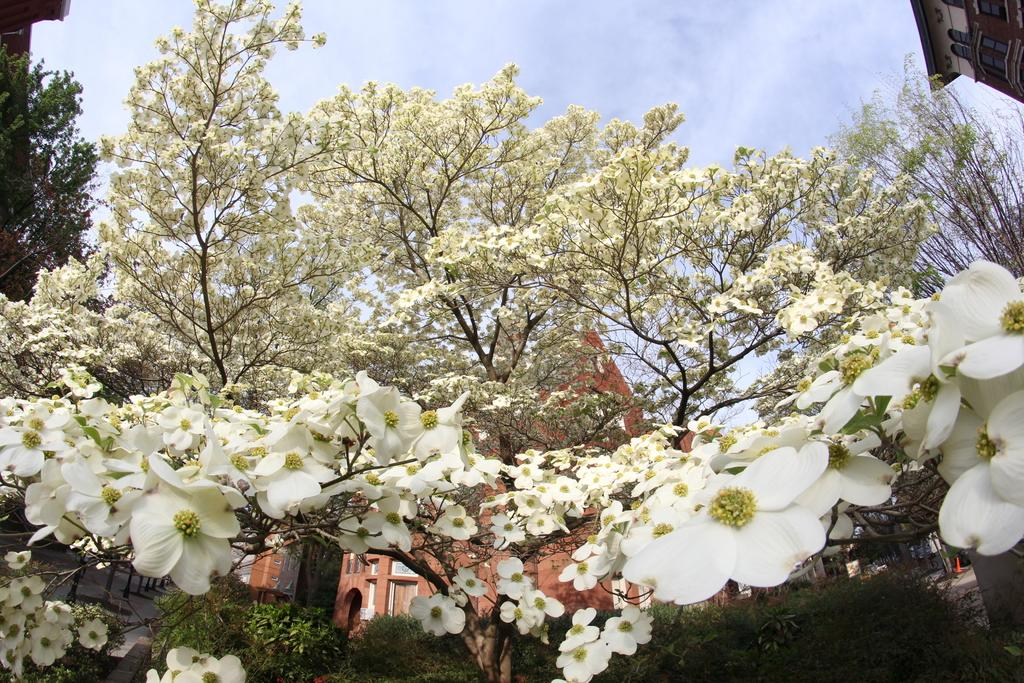What type of vegetation can be seen in the image? There are trees in the image. What color are the flowers that are visible in the image? There are white-colored flowers in the image. What type of structures can be seen in the image? There are buildings in the image. What is visible in the background of the image? The sky is visible in the background of the image. What type of bubble can be seen floating in the image? There is no bubble present in the image. What type of cork is used to seal the wine bottle in the image? There is no wine bottle present in the image. 